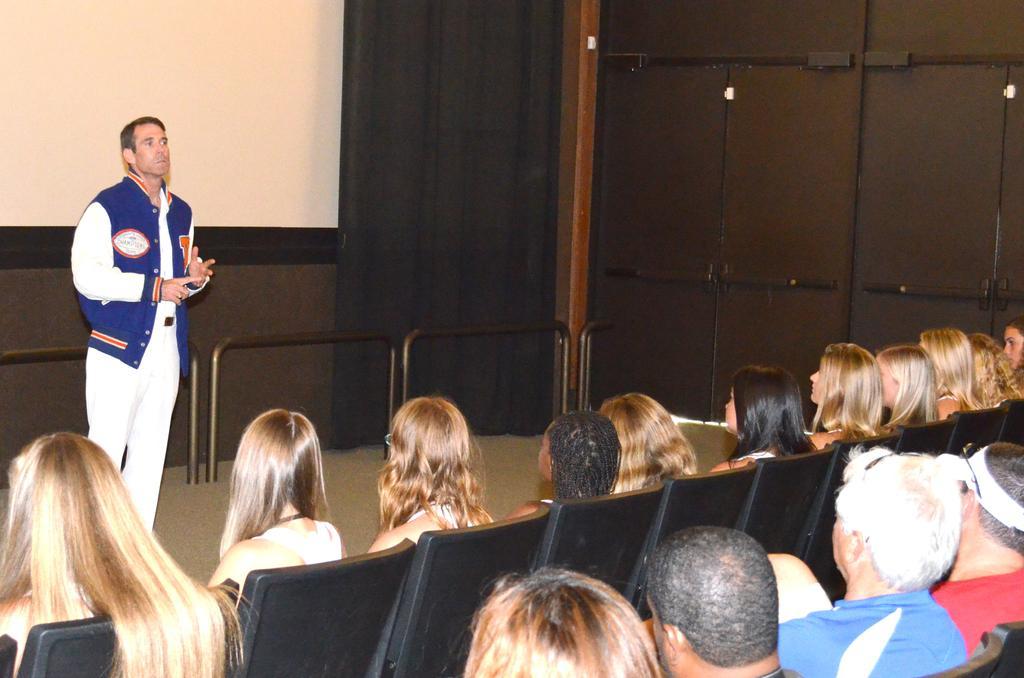Can you describe this image briefly? This image is taken indoors. In the background there is a wall and there is a screen on the wall. At the bottom of the image many people are sitting on the chairs. On the left side of the image a man is standing on the floor and talking. 